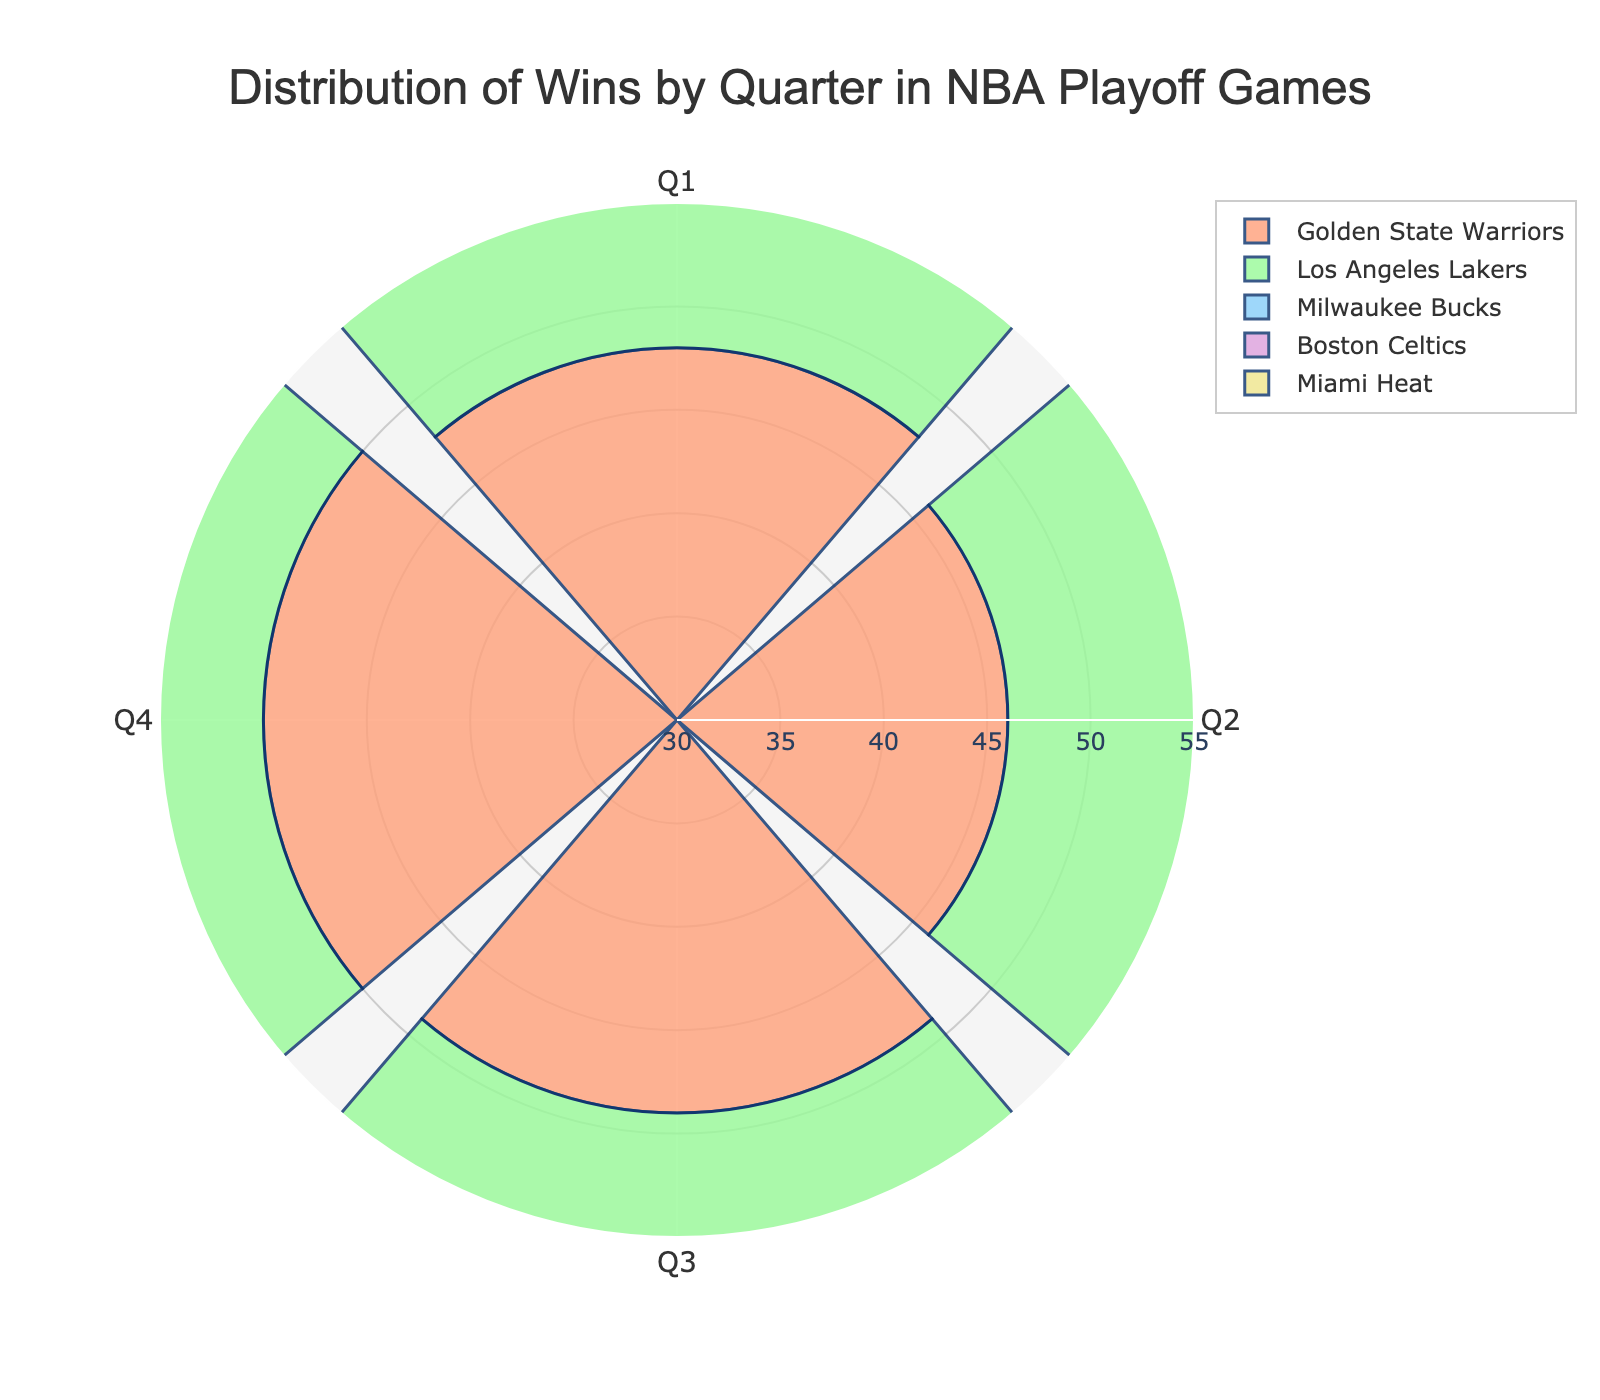What is the title of the chart? The title is typically located at the top of the chart. In this case, the title is written explicitly in the provided code.
Answer: Distribution of Wins by Quarter in NBA Playoff Games How many teams are represented in the chart? The chart has different segments for each team, and their names can be identified in the legend. The first color circle gives an idea of the teams. Counting these unique teams will give the answer.
Answer: 5 Which team has the highest number of wins in the fourth quarter? By examining the segments in the fourth quarter, we identify the team with the longest radial bar. The data and visual strongly indicate this.
Answer: Golden State Warriors In which quarter did the Miami Heat win the least games? Checking the radial lengths of each of the Miami Heat's segments across all quarters will show the shortest one.
Answer: Third quarter (Q3) What is the total number of wins for the Boston Celtics across all quarters? Sum up all the Boston Celtics wins indicated on the chart. The data lists them as 42 + 40 + 41 + 43.
Answer: 166 Compare the second quarter wins of the Los Angeles Lakers and Milwaukee Bucks. Which team has more wins? Look at the second quarter segment for both teams. The visual lengths and data provided will show the comparison, 47 for Lakers, 43 for Bucks.
Answer: Los Angeles Lakers Which quarter shows the most wins for the Golden State Warriors? Identify the longest radial segment for the Golden State Warriors across all quarters according to the chart. The chart shows different lengths for each quarter and the longest corresponds to the fourth quarter.
Answer: Fourth quarter (Q4) Are there any quarters where the Boston Celtics have fewer or equal wins compared to the Miami Heat? If so, which ones? Compare the radial segments for both teams for each quarter. They have more wins in all quarters, as visually confirmed and backed by data values (Boston's minimum is 40, while Miami's maximum is 40).
Answer: No, there are no such quarters What is the average number of wins in the first quarter for all teams combined? To find this, sum the wins of all teams in the first quarter and divide by the number of teams. Adding the values (48 + 45 + 44 + 42 + 39) = 218, then 218/5 = 43.6.
Answer: 43.6 Look at Milwaukee Bucks' performance in terms of wins across different quarters. Which quarter has the maximum wins, and what's the count? From the chart, identify which quarter's radial segment for Milwaukee Bucks is the longest. The third quarter with 46 wins is the longest.
Answer: Third quarter (46) 